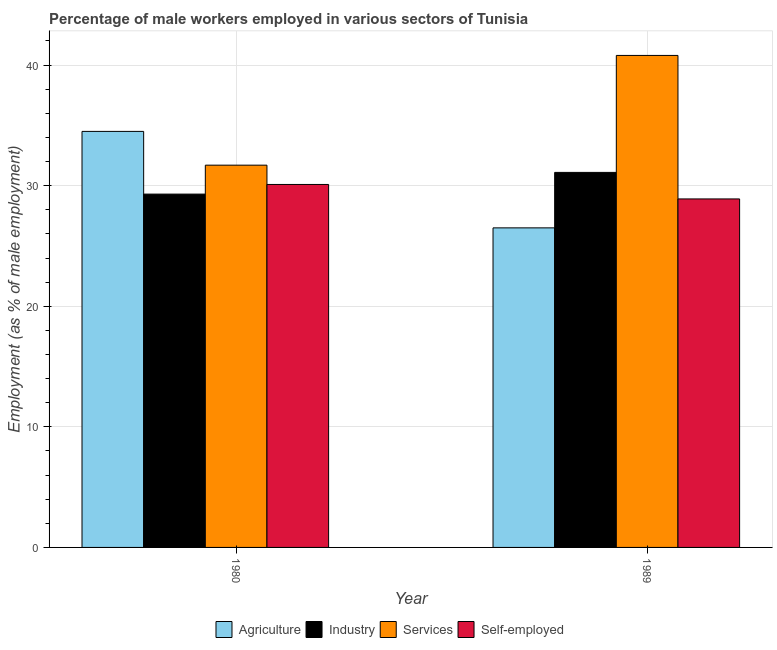How many different coloured bars are there?
Keep it short and to the point. 4. Are the number of bars per tick equal to the number of legend labels?
Ensure brevity in your answer.  Yes. Are the number of bars on each tick of the X-axis equal?
Give a very brief answer. Yes. What is the label of the 2nd group of bars from the left?
Your answer should be compact. 1989. In how many cases, is the number of bars for a given year not equal to the number of legend labels?
Offer a terse response. 0. What is the percentage of male workers in industry in 1989?
Offer a very short reply. 31.1. Across all years, what is the maximum percentage of male workers in agriculture?
Your response must be concise. 34.5. Across all years, what is the minimum percentage of male workers in industry?
Offer a terse response. 29.3. In which year was the percentage of self employed male workers minimum?
Your response must be concise. 1989. What is the difference between the percentage of male workers in agriculture in 1980 and that in 1989?
Offer a very short reply. 8. What is the difference between the percentage of male workers in industry in 1989 and the percentage of male workers in agriculture in 1980?
Provide a succinct answer. 1.8. What is the average percentage of self employed male workers per year?
Your answer should be compact. 29.5. In how many years, is the percentage of self employed male workers greater than 26 %?
Offer a terse response. 2. What is the ratio of the percentage of male workers in agriculture in 1980 to that in 1989?
Offer a very short reply. 1.3. Is it the case that in every year, the sum of the percentage of male workers in agriculture and percentage of self employed male workers is greater than the sum of percentage of male workers in industry and percentage of male workers in services?
Provide a short and direct response. Yes. What does the 2nd bar from the left in 1980 represents?
Ensure brevity in your answer.  Industry. What does the 2nd bar from the right in 1989 represents?
Your answer should be compact. Services. Is it the case that in every year, the sum of the percentage of male workers in agriculture and percentage of male workers in industry is greater than the percentage of male workers in services?
Keep it short and to the point. Yes. How many years are there in the graph?
Provide a succinct answer. 2. Does the graph contain grids?
Your answer should be compact. Yes. What is the title of the graph?
Offer a very short reply. Percentage of male workers employed in various sectors of Tunisia. What is the label or title of the X-axis?
Offer a very short reply. Year. What is the label or title of the Y-axis?
Your answer should be compact. Employment (as % of male employment). What is the Employment (as % of male employment) in Agriculture in 1980?
Keep it short and to the point. 34.5. What is the Employment (as % of male employment) of Industry in 1980?
Make the answer very short. 29.3. What is the Employment (as % of male employment) of Services in 1980?
Make the answer very short. 31.7. What is the Employment (as % of male employment) in Self-employed in 1980?
Your answer should be very brief. 30.1. What is the Employment (as % of male employment) in Industry in 1989?
Provide a short and direct response. 31.1. What is the Employment (as % of male employment) of Services in 1989?
Make the answer very short. 40.8. What is the Employment (as % of male employment) of Self-employed in 1989?
Ensure brevity in your answer.  28.9. Across all years, what is the maximum Employment (as % of male employment) in Agriculture?
Provide a short and direct response. 34.5. Across all years, what is the maximum Employment (as % of male employment) of Industry?
Your answer should be compact. 31.1. Across all years, what is the maximum Employment (as % of male employment) of Services?
Make the answer very short. 40.8. Across all years, what is the maximum Employment (as % of male employment) of Self-employed?
Give a very brief answer. 30.1. Across all years, what is the minimum Employment (as % of male employment) of Agriculture?
Keep it short and to the point. 26.5. Across all years, what is the minimum Employment (as % of male employment) in Industry?
Offer a terse response. 29.3. Across all years, what is the minimum Employment (as % of male employment) of Services?
Keep it short and to the point. 31.7. Across all years, what is the minimum Employment (as % of male employment) in Self-employed?
Give a very brief answer. 28.9. What is the total Employment (as % of male employment) in Industry in the graph?
Your answer should be very brief. 60.4. What is the total Employment (as % of male employment) in Services in the graph?
Provide a short and direct response. 72.5. What is the difference between the Employment (as % of male employment) of Agriculture in 1980 and that in 1989?
Your answer should be very brief. 8. What is the difference between the Employment (as % of male employment) in Industry in 1980 and that in 1989?
Offer a very short reply. -1.8. What is the difference between the Employment (as % of male employment) of Self-employed in 1980 and that in 1989?
Your answer should be very brief. 1.2. What is the difference between the Employment (as % of male employment) in Agriculture in 1980 and the Employment (as % of male employment) in Services in 1989?
Offer a terse response. -6.3. What is the difference between the Employment (as % of male employment) in Agriculture in 1980 and the Employment (as % of male employment) in Self-employed in 1989?
Keep it short and to the point. 5.6. What is the difference between the Employment (as % of male employment) of Industry in 1980 and the Employment (as % of male employment) of Services in 1989?
Your answer should be very brief. -11.5. What is the difference between the Employment (as % of male employment) of Industry in 1980 and the Employment (as % of male employment) of Self-employed in 1989?
Offer a terse response. 0.4. What is the average Employment (as % of male employment) in Agriculture per year?
Provide a short and direct response. 30.5. What is the average Employment (as % of male employment) of Industry per year?
Give a very brief answer. 30.2. What is the average Employment (as % of male employment) in Services per year?
Your answer should be compact. 36.25. What is the average Employment (as % of male employment) in Self-employed per year?
Your answer should be very brief. 29.5. In the year 1980, what is the difference between the Employment (as % of male employment) in Agriculture and Employment (as % of male employment) in Industry?
Make the answer very short. 5.2. In the year 1980, what is the difference between the Employment (as % of male employment) in Agriculture and Employment (as % of male employment) in Self-employed?
Your answer should be compact. 4.4. In the year 1980, what is the difference between the Employment (as % of male employment) in Industry and Employment (as % of male employment) in Self-employed?
Offer a very short reply. -0.8. In the year 1980, what is the difference between the Employment (as % of male employment) in Services and Employment (as % of male employment) in Self-employed?
Your response must be concise. 1.6. In the year 1989, what is the difference between the Employment (as % of male employment) of Agriculture and Employment (as % of male employment) of Industry?
Offer a terse response. -4.6. In the year 1989, what is the difference between the Employment (as % of male employment) of Agriculture and Employment (as % of male employment) of Services?
Your answer should be compact. -14.3. In the year 1989, what is the difference between the Employment (as % of male employment) of Agriculture and Employment (as % of male employment) of Self-employed?
Provide a succinct answer. -2.4. In the year 1989, what is the difference between the Employment (as % of male employment) of Services and Employment (as % of male employment) of Self-employed?
Your response must be concise. 11.9. What is the ratio of the Employment (as % of male employment) of Agriculture in 1980 to that in 1989?
Make the answer very short. 1.3. What is the ratio of the Employment (as % of male employment) of Industry in 1980 to that in 1989?
Offer a terse response. 0.94. What is the ratio of the Employment (as % of male employment) in Services in 1980 to that in 1989?
Offer a very short reply. 0.78. What is the ratio of the Employment (as % of male employment) in Self-employed in 1980 to that in 1989?
Offer a very short reply. 1.04. What is the difference between the highest and the lowest Employment (as % of male employment) in Agriculture?
Provide a short and direct response. 8. What is the difference between the highest and the lowest Employment (as % of male employment) in Services?
Provide a short and direct response. 9.1. What is the difference between the highest and the lowest Employment (as % of male employment) in Self-employed?
Make the answer very short. 1.2. 